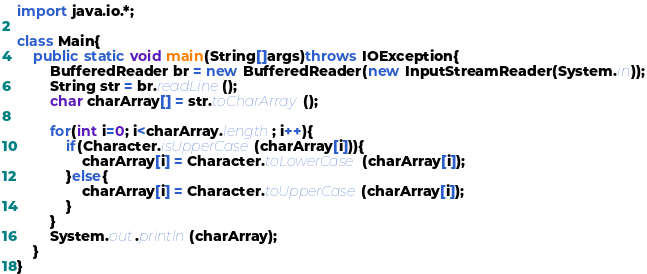<code> <loc_0><loc_0><loc_500><loc_500><_Java_>import java.io.*;

class Main{
    public static void main(String[]args)throws IOException{
        BufferedReader br = new BufferedReader(new InputStreamReader(System.in));
        String str = br.readLine();
        char charArray[] = str.toCharArray();
        
        for(int i=0; i<charArray.length; i++){
            if(Character.isUpperCase(charArray[i])){
                charArray[i] = Character.toLowerCase(charArray[i]);
            }else{
                charArray[i] = Character.toUpperCase(charArray[i]);
            }
        }
        System.out.println(charArray);
    }
}</code> 